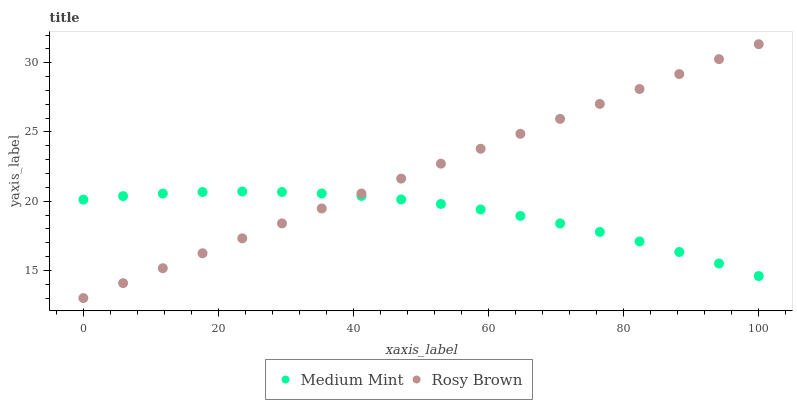Does Medium Mint have the minimum area under the curve?
Answer yes or no. Yes. Does Rosy Brown have the maximum area under the curve?
Answer yes or no. Yes. Does Rosy Brown have the minimum area under the curve?
Answer yes or no. No. Is Rosy Brown the smoothest?
Answer yes or no. Yes. Is Medium Mint the roughest?
Answer yes or no. Yes. Is Rosy Brown the roughest?
Answer yes or no. No. Does Rosy Brown have the lowest value?
Answer yes or no. Yes. Does Rosy Brown have the highest value?
Answer yes or no. Yes. Does Rosy Brown intersect Medium Mint?
Answer yes or no. Yes. Is Rosy Brown less than Medium Mint?
Answer yes or no. No. Is Rosy Brown greater than Medium Mint?
Answer yes or no. No. 